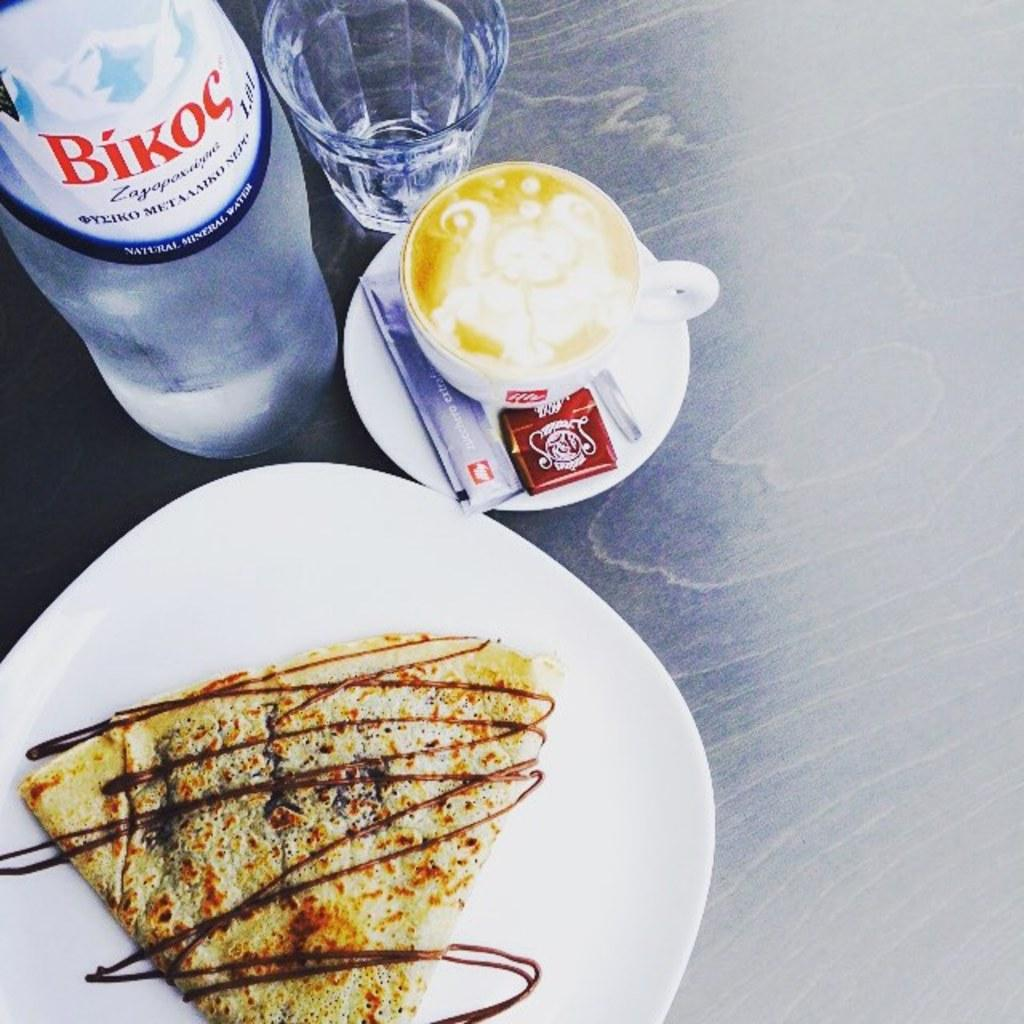<image>
Offer a succinct explanation of the picture presented. A bottle of Bikoc sits next to a coffee and a crepe on a plate. 